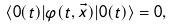Convert formula to latex. <formula><loc_0><loc_0><loc_500><loc_500>\langle 0 ( t ) | \varphi ( t , \vec { x } ) | 0 ( t ) \rangle = 0 ,</formula> 